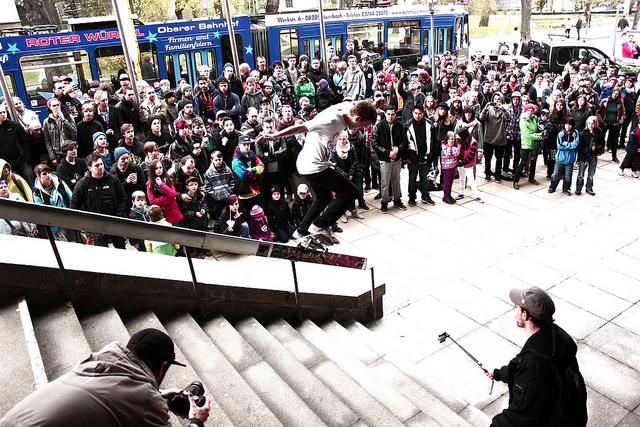What is the photographer at the bottom of the stairs holding?
Write a very short answer. Microphone. What are the people staring at?
Write a very short answer. Skateboarder. What color is the bus in the background?
Write a very short answer. Blue. 